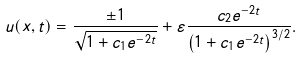Convert formula to latex. <formula><loc_0><loc_0><loc_500><loc_500>u ( x , t ) = \frac { \pm 1 } { \sqrt { 1 + c _ { 1 } e ^ { - 2 t } } } + \varepsilon \frac { c _ { 2 } e ^ { - 2 t } } { \left ( 1 + c _ { 1 } e ^ { - 2 t } \right ) ^ { 3 / 2 } } .</formula> 